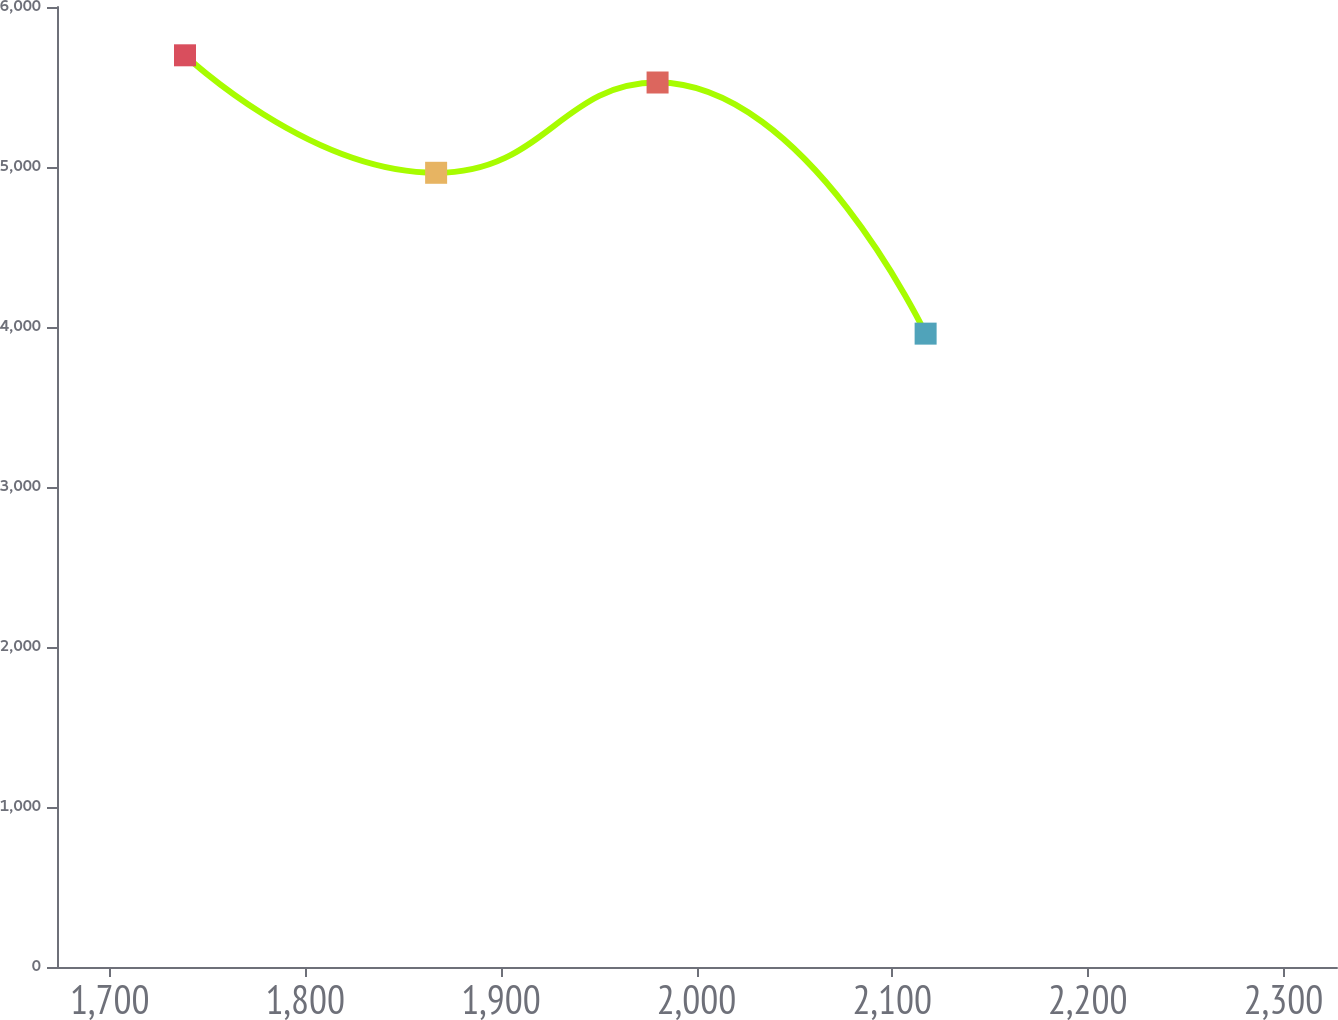Convert chart to OTSL. <chart><loc_0><loc_0><loc_500><loc_500><line_chart><ecel><fcel>Unnamed: 1<nl><fcel>1738.5<fcel>5698.12<nl><fcel>1866.87<fcel>4963.8<nl><fcel>1980.07<fcel>5528.09<nl><fcel>2117.09<fcel>3958.57<nl><fcel>2392.81<fcel>4692.32<nl></chart> 